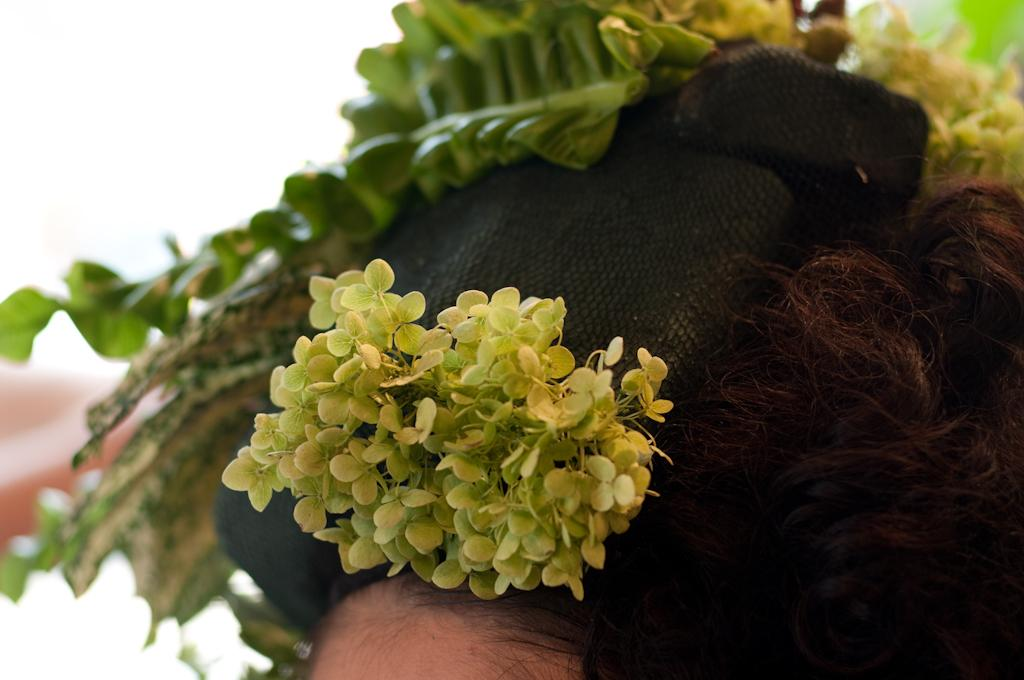What is the main subject of the image? There is a human head in the image. What is covering the head? There is a cap on the head. What is a natural feature of the head that can be seen in the image? Hair is visible on the head. What type of vegetation is present in the image? Leaves are present in the image. Where is the water flowing in the image? There is no water present in the image. What type of paper can be seen in the image? There is no paper present in the image. 